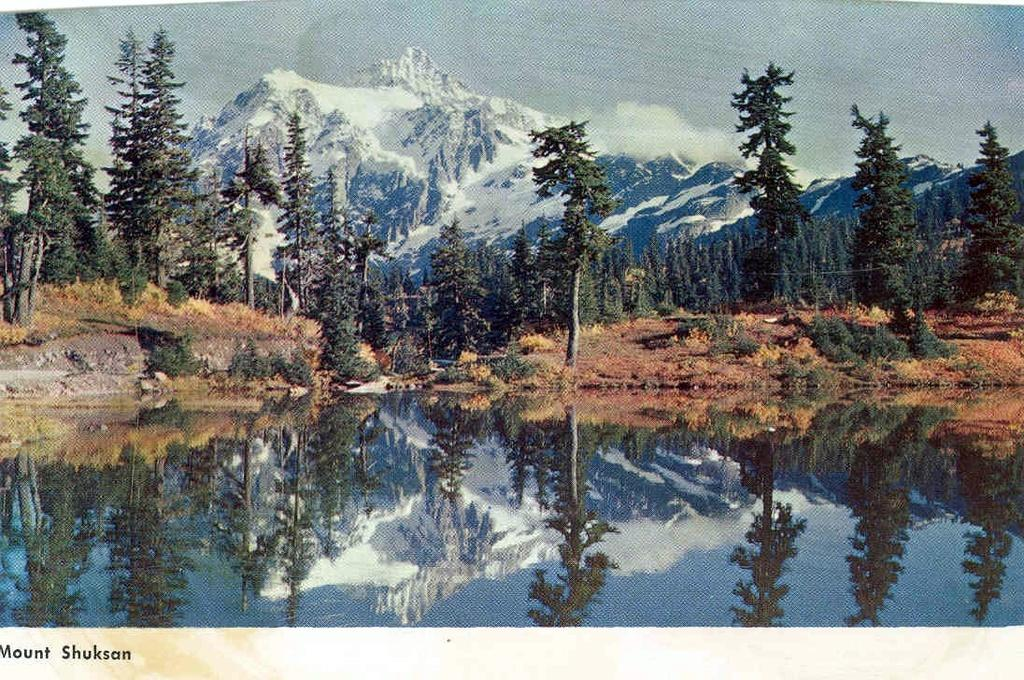What is present at the bottom of the image? There is water at the bottom of the image. What can be seen in the middle of the image? There are trees in the middle of the image. What type of geographical feature is visible at the back side of the image? There are mountains with snow at the back side of the image. Where is the clover located in the image? There is no clover present in the image. What type of mailbox can be seen near the trees in the image? There is no mailbox present in the image. 